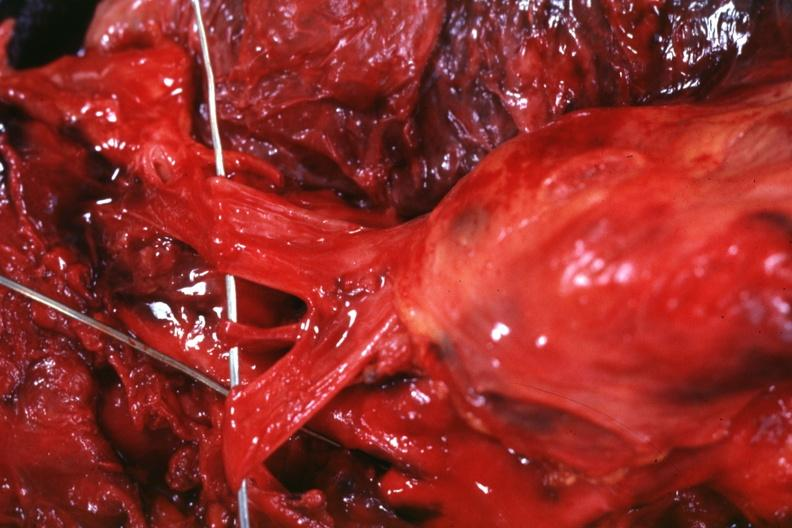what is present?
Answer the question using a single word or phrase. Malignant thymoma 